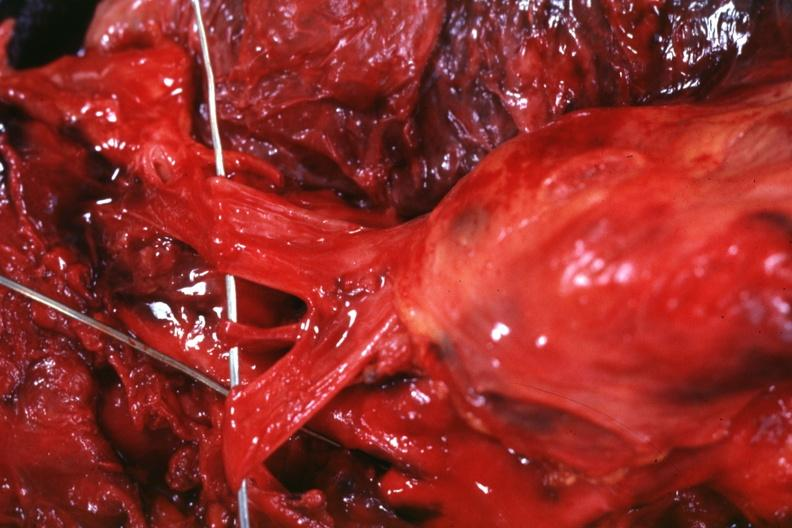what is present?
Answer the question using a single word or phrase. Malignant thymoma 